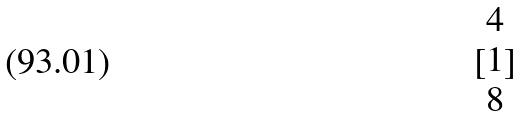<formula> <loc_0><loc_0><loc_500><loc_500>[ \begin{matrix} 4 \\ 1 \\ 8 \end{matrix} ]</formula> 